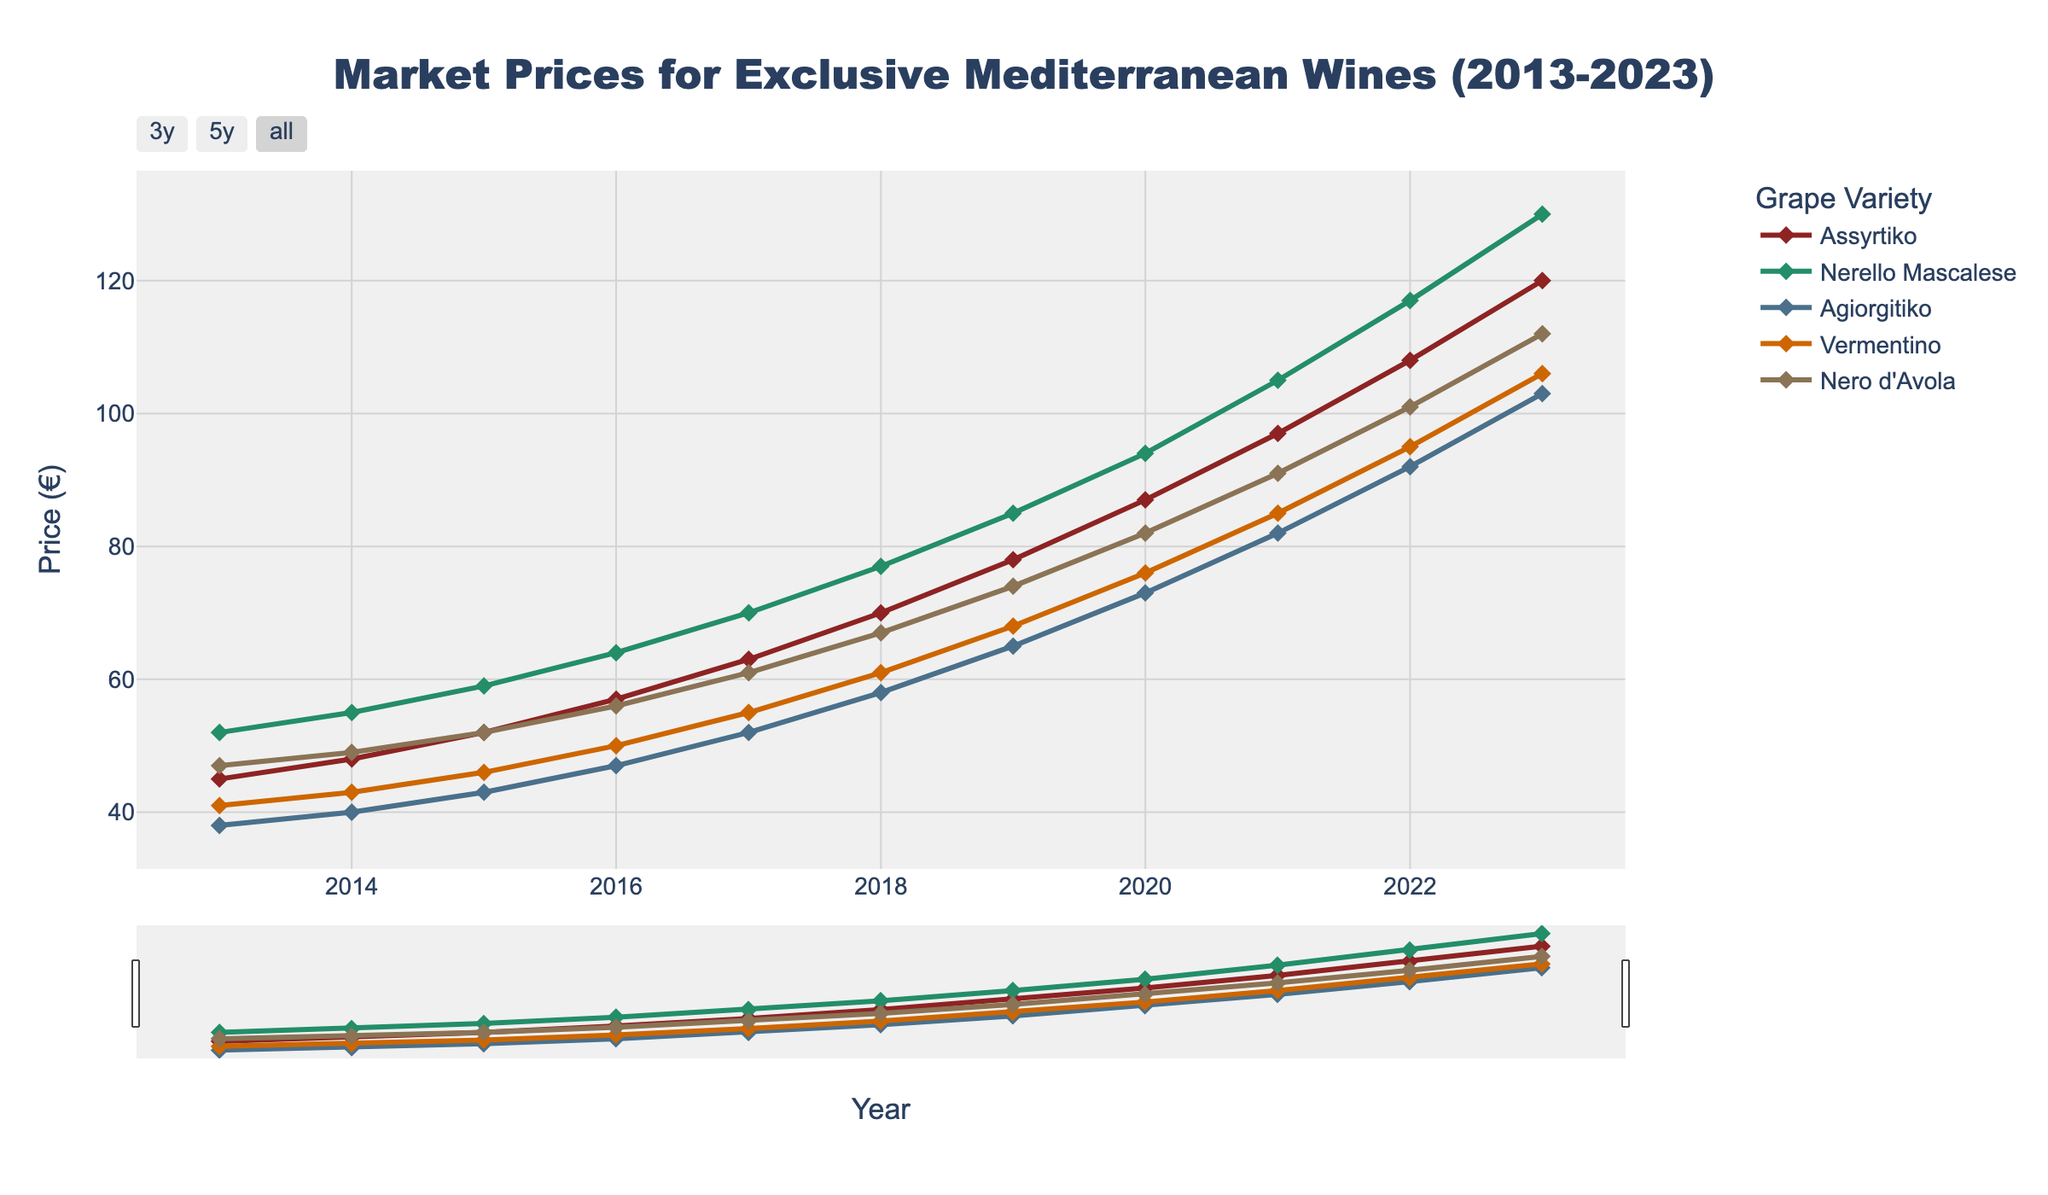What year did Assyrtiko surpass 100 euros in market price? Examine the plot and notice the price trend for Assyrtiko. It crossed the 100€ mark in 2021.
Answer: 2021 Which grape variety had the highest market price in 2023? Look at the peak values of all lines in 2023, and identify the highest. Nerello Mascalese reaches 130€.
Answer: Nerello Mascalese How many years did it take for Agiorgitiko to increase from 38€ to 103€? Agiorgitiko started at 38€ in 2013 and reached 103€ in 2023. Count the years between 2013 and 2023.
Answer: 10 years Compare the market prices of Vermentino and Nero d'Avola in 2017. Which one was higher and by how much? In 2017, Vermentino was priced at 55€ and Nero d'Avola at 61€. The difference is 6€.
Answer: Nero d'Avola by 6€ Does the market price of Assyrtiko follow an increasing, decreasing, or fluctuating trend over the decade? Observe the line representing Assyrtiko. It shows a consistent upward trend without any decreases or fluctuations.
Answer: Increasing Calculate the average increase in price per year for Nero d'Avola from 2013 to 2023. In 2013, the price was 47€, and in 2023, it was 112€. The increase over 10 years is 112€ - 47€ = 65€. The average yearly increase is 65€/10 = 6.5€.
Answer: 6.5€ Which grape variety showed the most significant price increase from 2013 to 2023? Calculate the price difference over the decade for each variety. The largest increase is for Nerello Mascalese (130€ - 52€ = 78€).
Answer: Nerello Mascalese Between 2018 and 2019, which grape variety saw the largest price increase? Compare the price changes for all varieties between 2018 and 2019. Assyrtiko rose by 78€ - 70€ = 8€.
Answer: Assyrtiko Did any grape variety price remain constant over the decade? Look for any flat horizontal lines in the plot, indicating no price changes. All lines show increasing trends.
Answer: No What's the average market price of Vermentino over the decade? Sum the prices of Vermentino from 2013 to 2023 and then divide by 11 for the average. (41 + 43 + 46 + 50 + 55 + 61 + 68 + 76 + 85 + 95 + 106)/11 = 65.63€
Answer: 65.63€ 